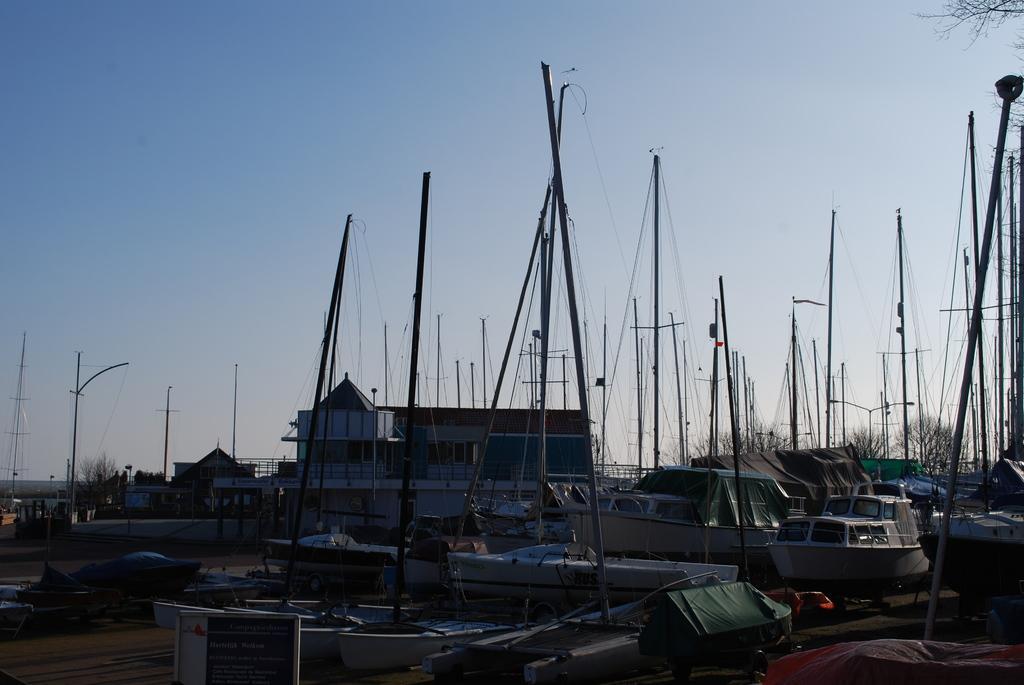Please provide a concise description of this image. In this image I can see many boats and the house. In the background I can see the trees and the sky. 